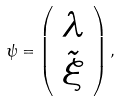Convert formula to latex. <formula><loc_0><loc_0><loc_500><loc_500>\psi = \left ( \begin{array} { c } \lambda \\ \tilde { \xi } \end{array} \right ) ,</formula> 